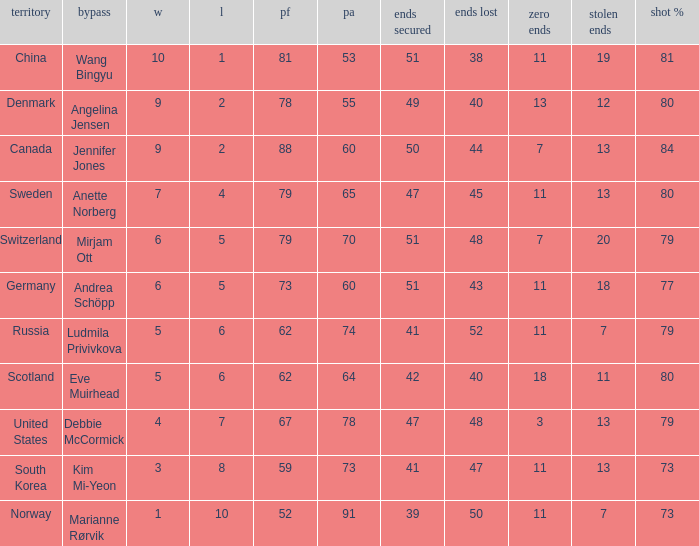What is Norway's least ends lost? 50.0. 